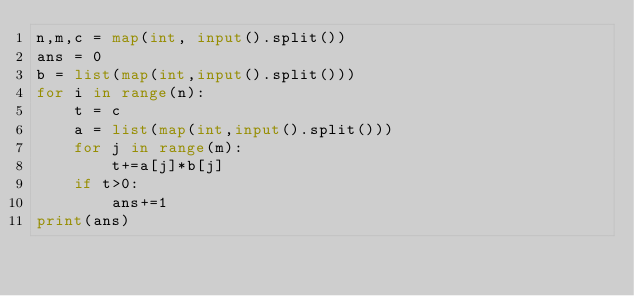Convert code to text. <code><loc_0><loc_0><loc_500><loc_500><_Python_>n,m,c = map(int, input().split())
ans = 0
b = list(map(int,input().split()))
for i in range(n):
    t = c
    a = list(map(int,input().split()))
    for j in range(m):
        t+=a[j]*b[j]
    if t>0:
        ans+=1
print(ans)</code> 